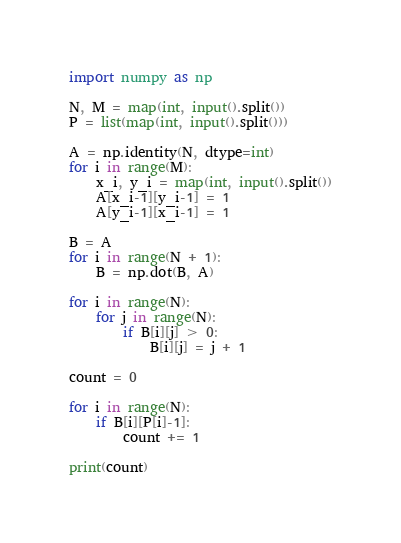<code> <loc_0><loc_0><loc_500><loc_500><_Python_>import numpy as np

N, M = map(int, input().split())
P = list(map(int, input().split()))

A = np.identity(N, dtype=int)
for i in range(M):
    x_i, y_i = map(int, input().split())
    A[x_i-1][y_i-1] = 1
    A[y_i-1][x_i-1] = 1

B = A
for i in range(N + 1):
    B = np.dot(B, A)

for i in range(N):
    for j in range(N):
        if B[i][j] > 0:
            B[i][j] = j + 1

count = 0

for i in range(N):
    if B[i][P[i]-1]:
        count += 1

print(count)
</code> 